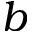<formula> <loc_0><loc_0><loc_500><loc_500>b</formula> 